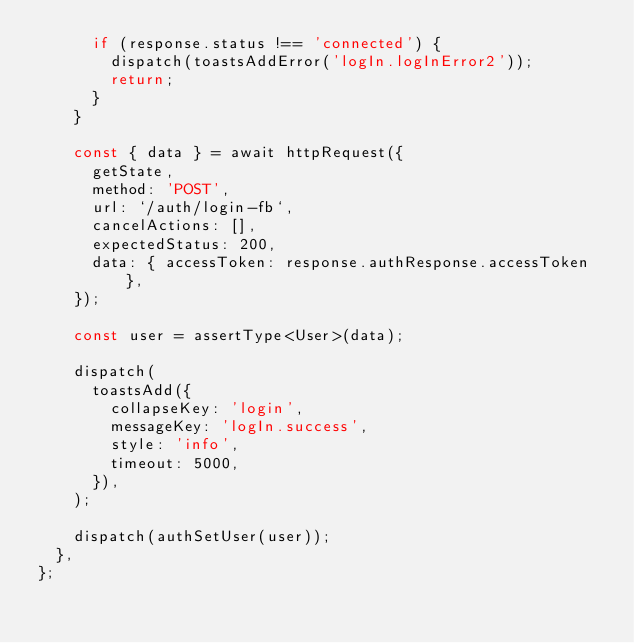<code> <loc_0><loc_0><loc_500><loc_500><_TypeScript_>      if (response.status !== 'connected') {
        dispatch(toastsAddError('logIn.logInError2'));
        return;
      }
    }

    const { data } = await httpRequest({
      getState,
      method: 'POST',
      url: `/auth/login-fb`,
      cancelActions: [],
      expectedStatus: 200,
      data: { accessToken: response.authResponse.accessToken },
    });

    const user = assertType<User>(data);

    dispatch(
      toastsAdd({
        collapseKey: 'login',
        messageKey: 'logIn.success',
        style: 'info',
        timeout: 5000,
      }),
    );

    dispatch(authSetUser(user));
  },
};
</code> 